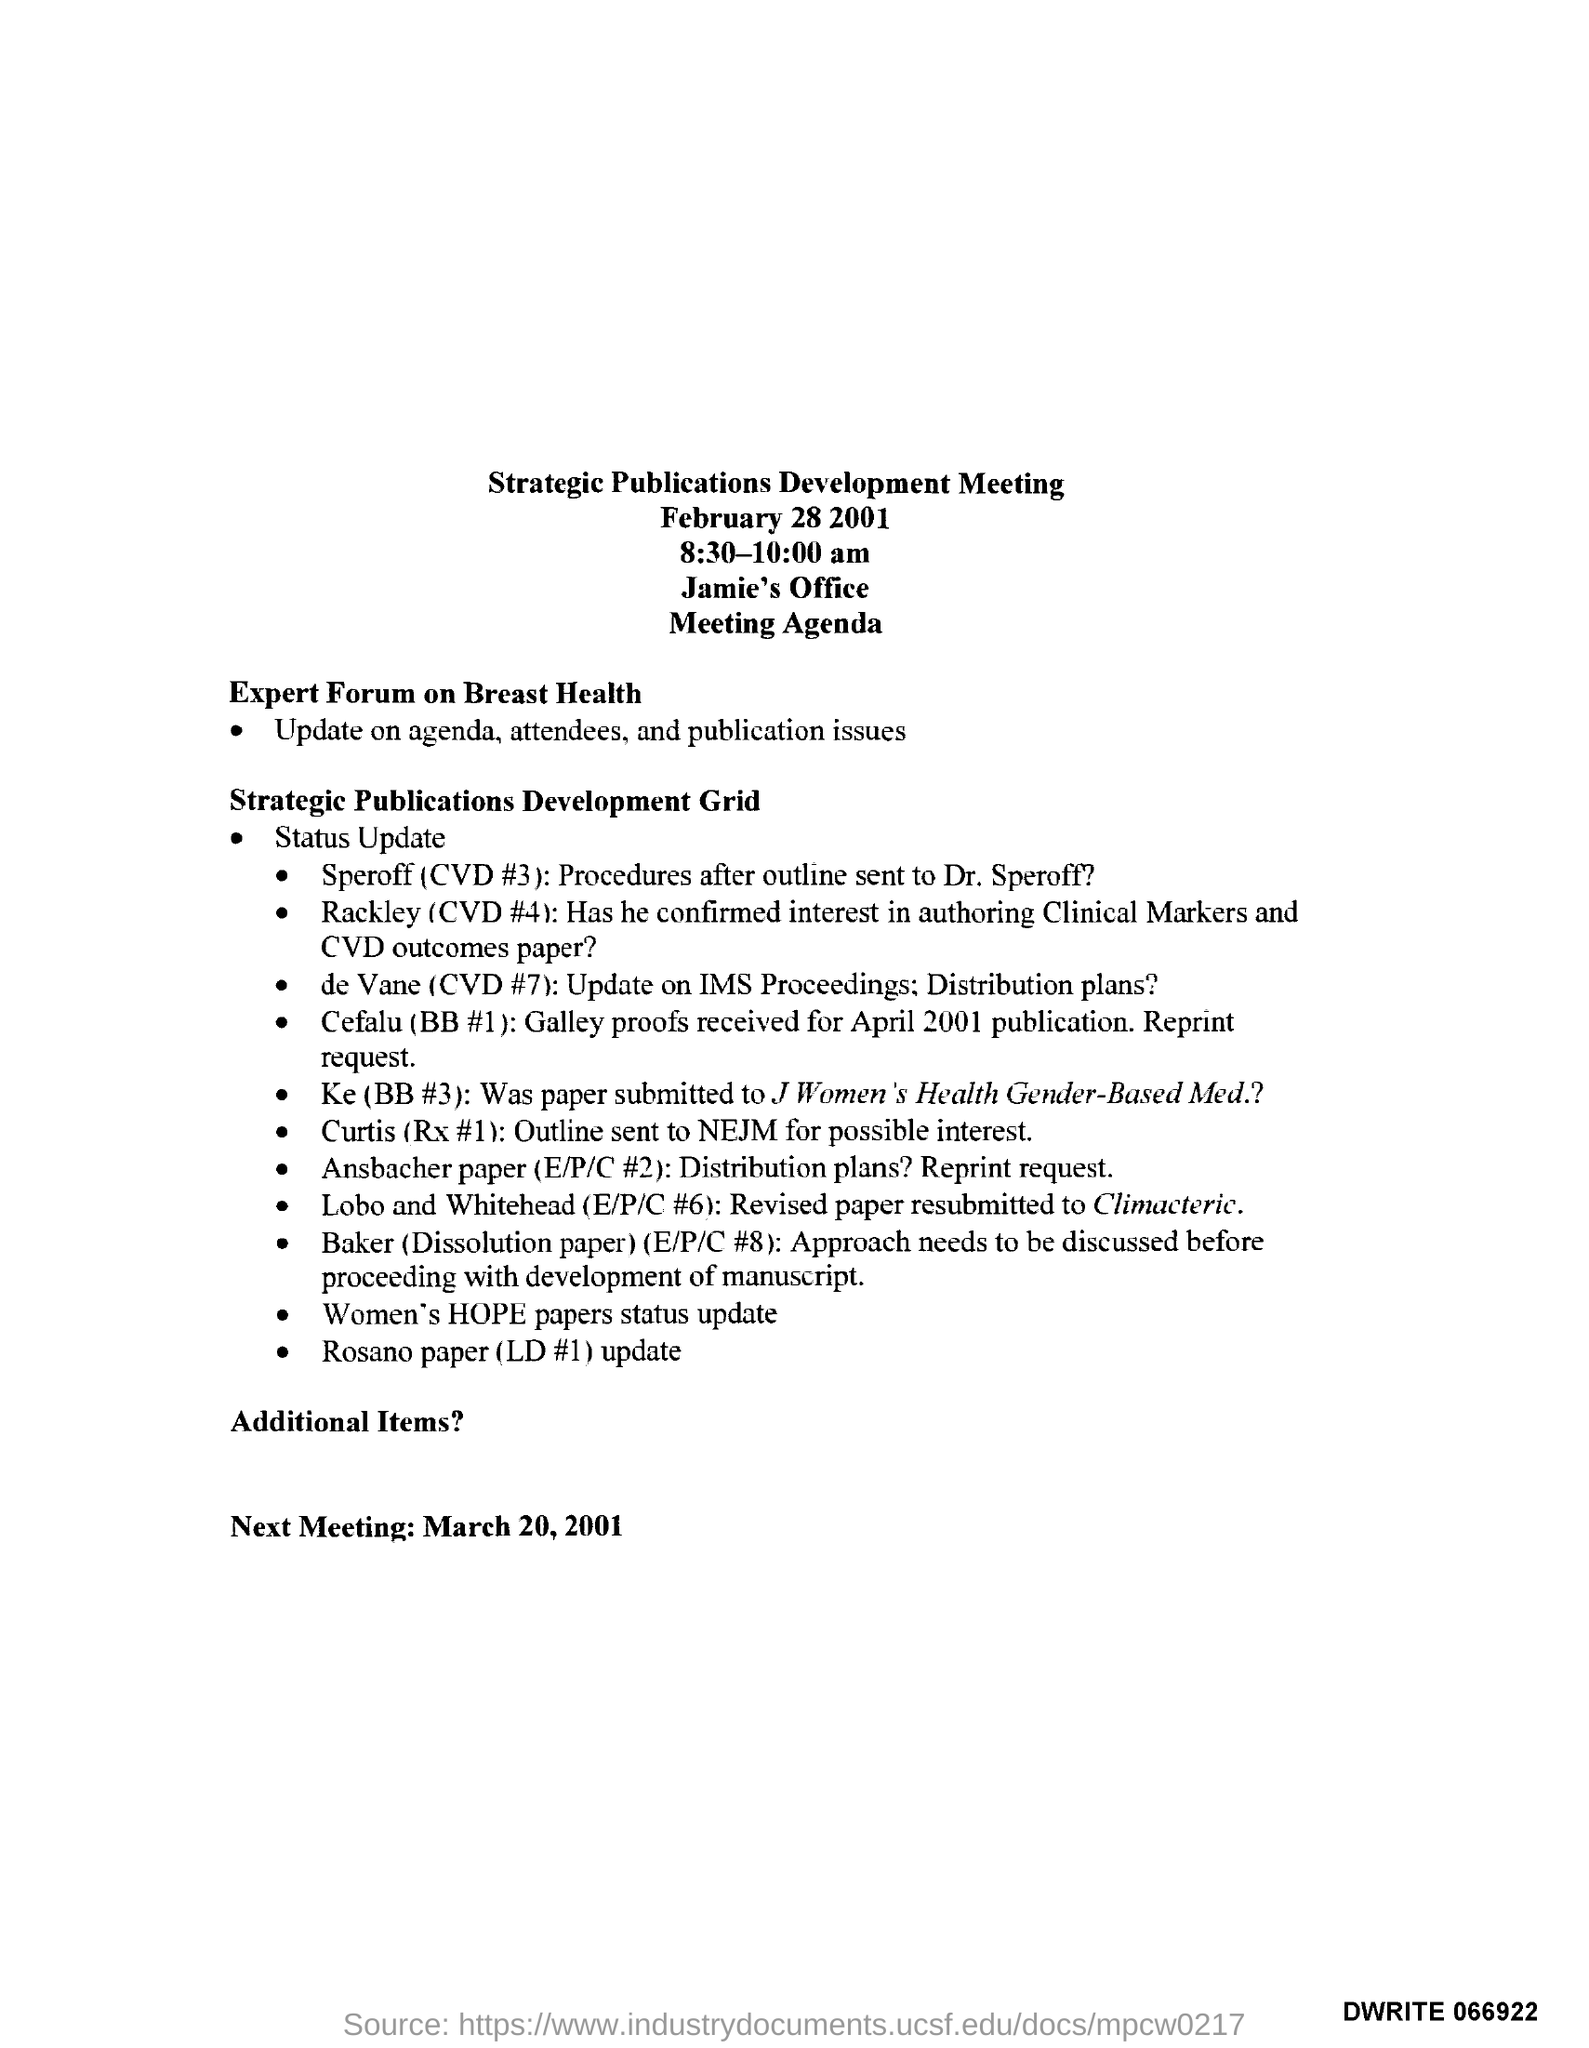When is the Strategic Publications Development Meeting held?
Keep it short and to the point. February 28 2001. What time is the Strategic Publications Development Meeting scheduled?
Provide a succinct answer. 8:30-10:00 am. In which place, the Strategic Publications Development Meeting is organized?
Keep it short and to the point. Jamie's Office. What update does the Expert Forum on Breast Health gives?
Offer a very short reply. Agenda, attendees, and publication issues. When is the next meeting scheduled as per the agenda?
Keep it short and to the point. March 20, 2001. 